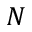<formula> <loc_0><loc_0><loc_500><loc_500>N</formula> 